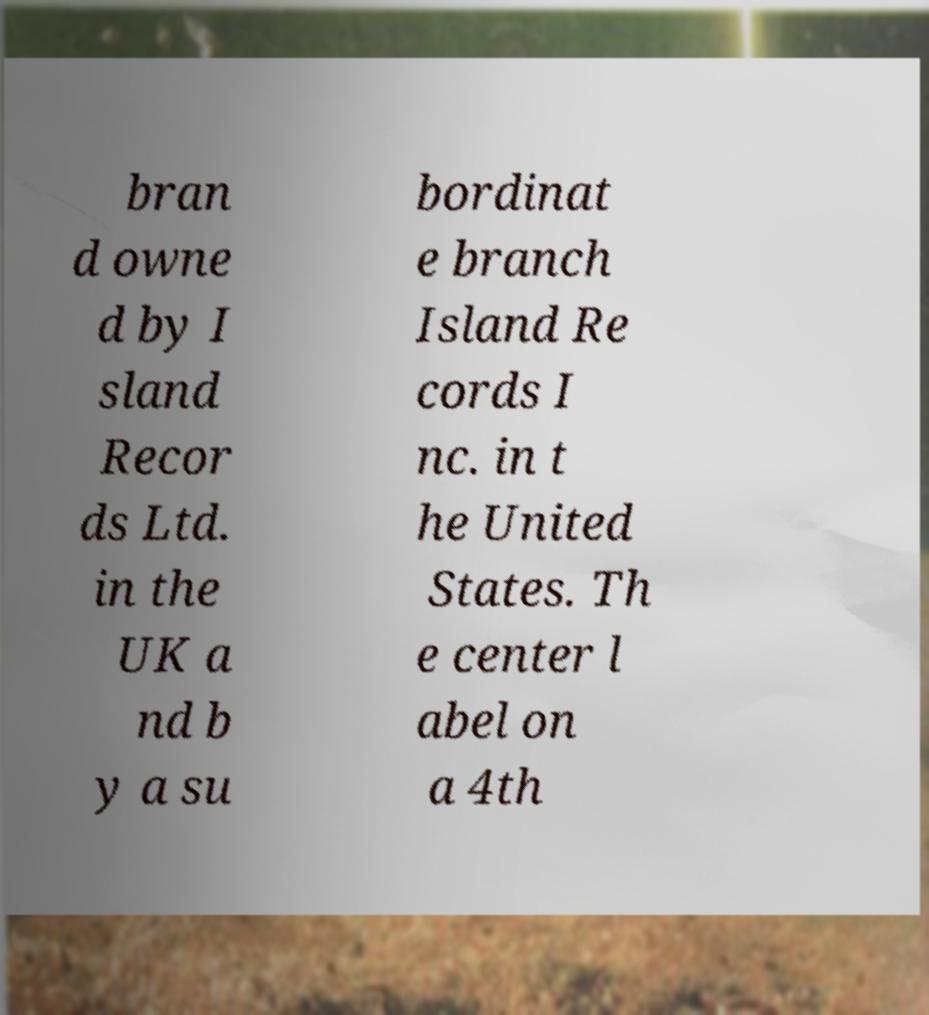For documentation purposes, I need the text within this image transcribed. Could you provide that? bran d owne d by I sland Recor ds Ltd. in the UK a nd b y a su bordinat e branch Island Re cords I nc. in t he United States. Th e center l abel on a 4th 